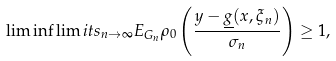<formula> <loc_0><loc_0><loc_500><loc_500>\lim \inf \lim i t s _ { n \rightarrow \infty } E _ { G _ { n } } \rho _ { 0 } \left ( \frac { y - \underline { g } ( x , \xi _ { n } ) } { \sigma _ { n } } \right ) \geq 1 ,</formula> 